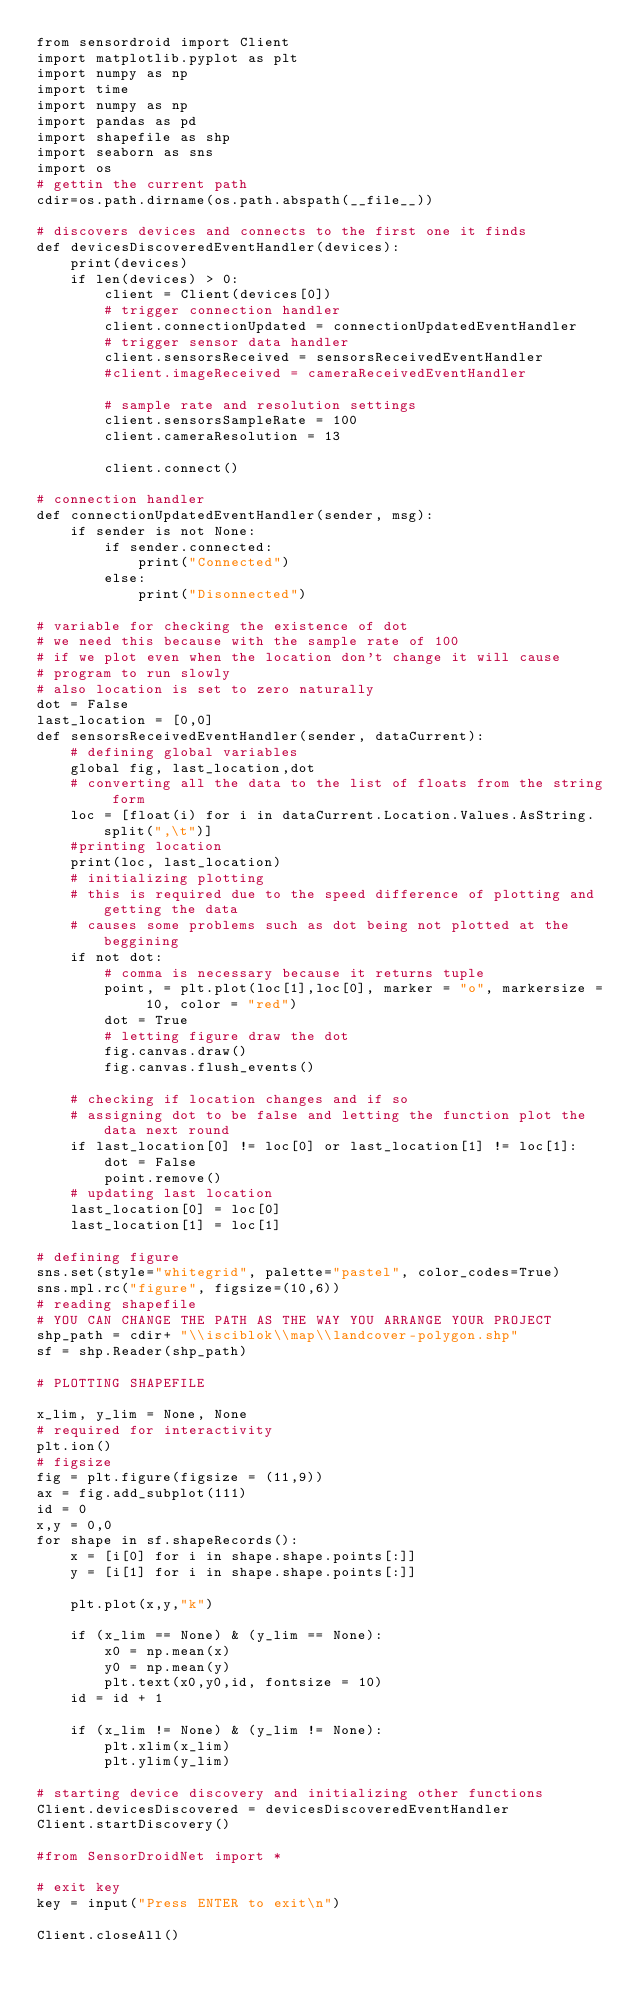Convert code to text. <code><loc_0><loc_0><loc_500><loc_500><_Python_>from sensordroid import Client
import matplotlib.pyplot as plt
import numpy as np
import time
import numpy as np
import pandas as pd
import shapefile as shp
import seaborn as sns
import os
# gettin the current path
cdir=os.path.dirname(os.path.abspath(__file__))

# discovers devices and connects to the first one it finds
def devicesDiscoveredEventHandler(devices):
    print(devices)
    if len(devices) > 0:
        client = Client(devices[0])
        # trigger connection handler
        client.connectionUpdated = connectionUpdatedEventHandler
        # trigger sensor data handler
        client.sensorsReceived = sensorsReceivedEventHandler
        #client.imageReceived = cameraReceivedEventHandler

        # sample rate and resolution settings
        client.sensorsSampleRate = 100
        client.cameraResolution = 13
        
        client.connect()
        
# connection handler
def connectionUpdatedEventHandler(sender, msg):
    if sender is not None:
        if sender.connected:
            print("Connected")
        else:
            print("Disonnected") 

# variable for checking the existence of dot
# we need this because with the sample rate of 100
# if we plot even when the location don't change it will cause
# program to run slowly
# also location is set to zero naturally
dot = False
last_location = [0,0]
def sensorsReceivedEventHandler(sender, dataCurrent):
    # defining global variables
    global fig, last_location,dot
    # converting all the data to the list of floats from the string form
    loc = [float(i) for i in dataCurrent.Location.Values.AsString.split(",\t")]
    #printing location 
    print(loc, last_location)
    # initializing plotting
    # this is required due to the speed difference of plotting and getting the data
    # causes some problems such as dot being not plotted at the beggining
    if not dot:
        # comma is necessary because it returns tuple
        point, = plt.plot(loc[1],loc[0], marker = "o", markersize = 10, color = "red")
        dot = True
        # letting figure draw the dot
        fig.canvas.draw()
        fig.canvas.flush_events()
        
    # checking if location changes and if so
    # assigning dot to be false and letting the function plot the data next round
    if last_location[0] != loc[0] or last_location[1] != loc[1]:
        dot = False
        point.remove()
    # updating last location
    last_location[0] = loc[0]
    last_location[1] = loc[1] 

# defining figure
sns.set(style="whitegrid", palette="pastel", color_codes=True)
sns.mpl.rc("figure", figsize=(10,6))
# reading shapefile
# YOU CAN CHANGE THE PATH AS THE WAY YOU ARRANGE YOUR PROJECT
shp_path = cdir+ "\\isciblok\\map\\landcover-polygon.shp"
sf = shp.Reader(shp_path)

# PLOTTING SHAPEFILE

x_lim, y_lim = None, None
# required for interactivity
plt.ion()
# figsize
fig = plt.figure(figsize = (11,9))
ax = fig.add_subplot(111)
id = 0
x,y = 0,0
for shape in sf.shapeRecords():
    x = [i[0] for i in shape.shape.points[:]]
    y = [i[1] for i in shape.shape.points[:]]

    plt.plot(x,y,"k")

    if (x_lim == None) & (y_lim == None):
        x0 = np.mean(x)
        y0 = np.mean(y)
        plt.text(x0,y0,id, fontsize = 10)
    id = id + 1

    if (x_lim != None) & (y_lim != None):     
        plt.xlim(x_lim)
        plt.ylim(y_lim)    

# starting device discovery and initializing other functions
Client.devicesDiscovered = devicesDiscoveredEventHandler
Client.startDiscovery()

#from SensorDroidNet import *

# exit key
key = input("Press ENTER to exit\n") 

Client.closeAll()</code> 